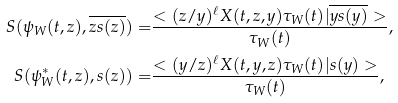<formula> <loc_0><loc_0><loc_500><loc_500>S ( \psi _ { W } ( t , z ) , \overline { z s ( z ) } ) = & \frac { < ( z / y ) ^ { \ell } X ( t , z , y ) \tau _ { W } ( t ) | \overline { y s ( y ) } > } { \tau _ { W } ( t ) } , \\ S ( \psi _ { W } ^ { * } ( t , z ) , s ( z ) ) = & \frac { < ( y / z ) ^ { \ell } X ( t , y , z ) \tau _ { W } ( t ) | s ( y ) > } { \tau _ { W } ( t ) } ,</formula> 